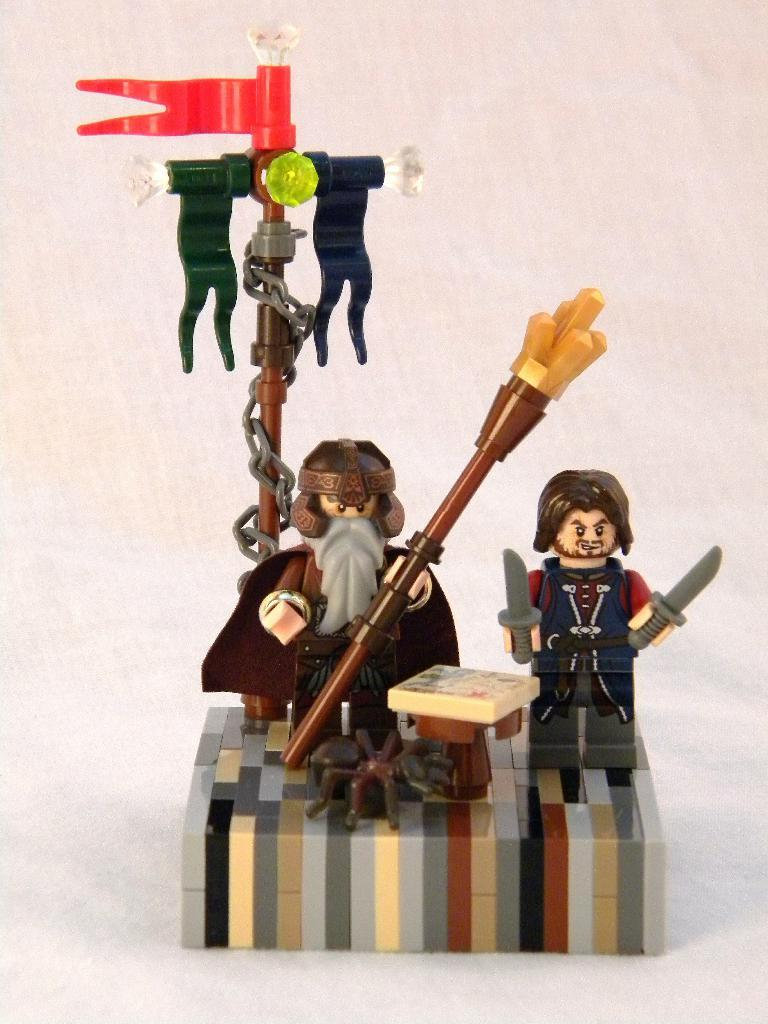What object is present in the image? There is a toy in the image. What feature does the toy have? The toy has flags. What color is the background of the image? The background of the image is white. How many boundaries are visible in the image? There are no boundaries visible in the image; it features a toy with flags against a white background. What type of beetle can be seen crawling on the toy in the image? There is no beetle present in the image; it only features a toy with flags against a white background. 